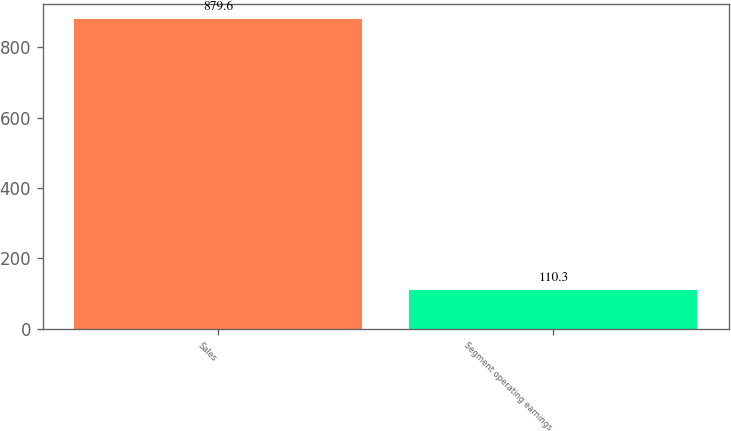Convert chart. <chart><loc_0><loc_0><loc_500><loc_500><bar_chart><fcel>Sales<fcel>Segment operating earnings<nl><fcel>879.6<fcel>110.3<nl></chart> 